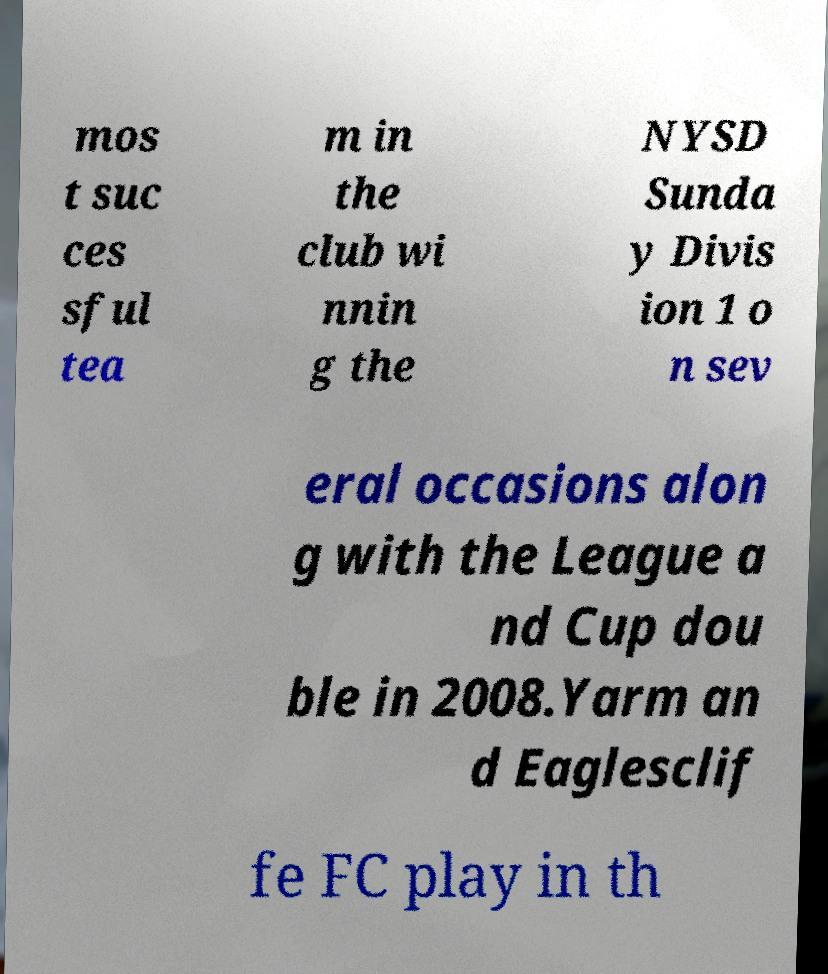I need the written content from this picture converted into text. Can you do that? mos t suc ces sful tea m in the club wi nnin g the NYSD Sunda y Divis ion 1 o n sev eral occasions alon g with the League a nd Cup dou ble in 2008.Yarm an d Eaglesclif fe FC play in th 